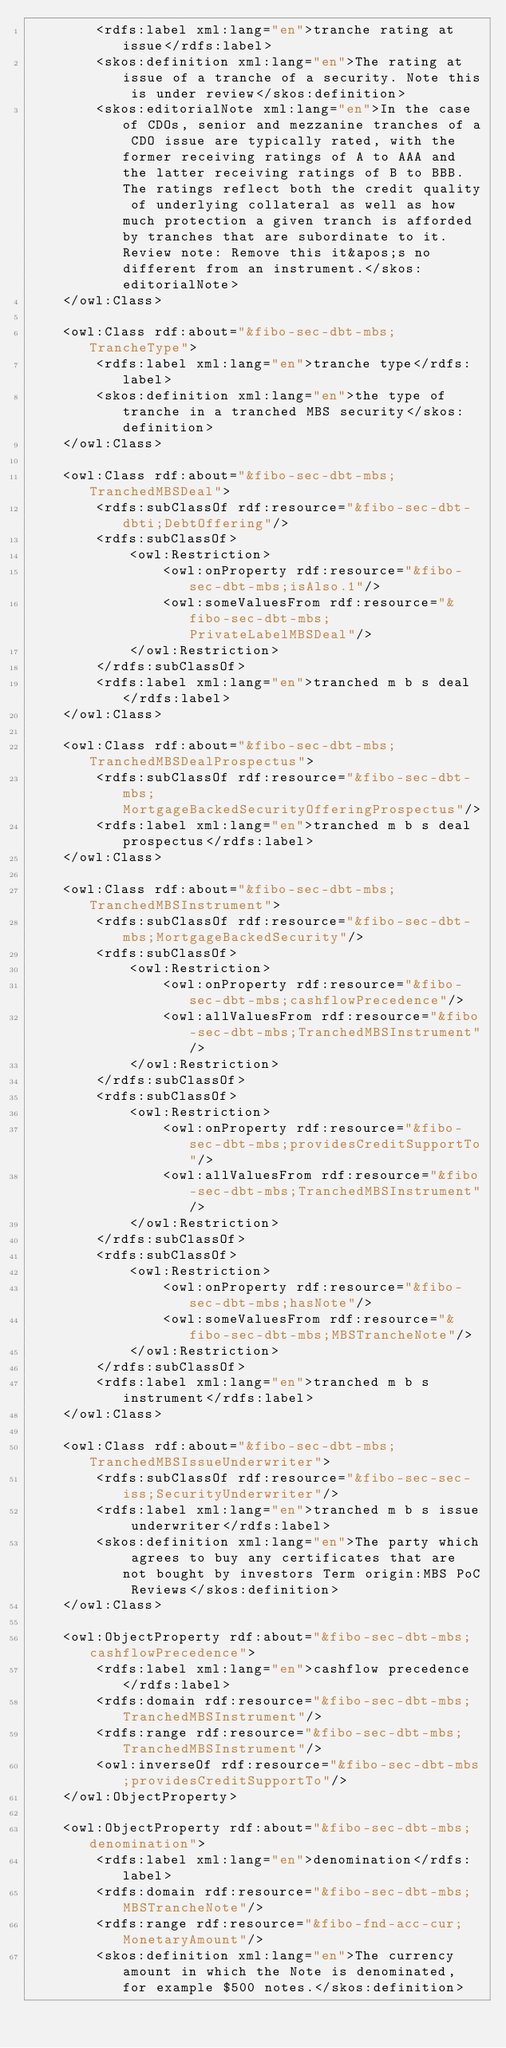Convert code to text. <code><loc_0><loc_0><loc_500><loc_500><_XML_>		<rdfs:label xml:lang="en">tranche rating at issue</rdfs:label>
		<skos:definition xml:lang="en">The rating at issue of a tranche of a security. Note this is under review</skos:definition>
		<skos:editorialNote xml:lang="en">In the case of CDOs, senior and mezzanine tranches of a CDO issue are typically rated, with the former receiving ratings of A to AAA and the latter receiving ratings of B to BBB. The ratings reflect both the credit quality of underlying collateral as well as how much protection a given tranch is afforded by tranches that are subordinate to it. Review note: Remove this it&apos;s no different from an instrument.</skos:editorialNote>
	</owl:Class>
	
	<owl:Class rdf:about="&fibo-sec-dbt-mbs;TrancheType">
		<rdfs:label xml:lang="en">tranche type</rdfs:label>
		<skos:definition xml:lang="en">the type of tranche in a tranched MBS security</skos:definition>
	</owl:Class>
	
	<owl:Class rdf:about="&fibo-sec-dbt-mbs;TranchedMBSDeal">
		<rdfs:subClassOf rdf:resource="&fibo-sec-dbt-dbti;DebtOffering"/>
		<rdfs:subClassOf>
			<owl:Restriction>
				<owl:onProperty rdf:resource="&fibo-sec-dbt-mbs;isAlso.1"/>
				<owl:someValuesFrom rdf:resource="&fibo-sec-dbt-mbs;PrivateLabelMBSDeal"/>
			</owl:Restriction>
		</rdfs:subClassOf>
		<rdfs:label xml:lang="en">tranched m b s deal</rdfs:label>
	</owl:Class>
	
	<owl:Class rdf:about="&fibo-sec-dbt-mbs;TranchedMBSDealProspectus">
		<rdfs:subClassOf rdf:resource="&fibo-sec-dbt-mbs;MortgageBackedSecurityOfferingProspectus"/>
		<rdfs:label xml:lang="en">tranched m b s deal prospectus</rdfs:label>
	</owl:Class>
	
	<owl:Class rdf:about="&fibo-sec-dbt-mbs;TranchedMBSInstrument">
		<rdfs:subClassOf rdf:resource="&fibo-sec-dbt-mbs;MortgageBackedSecurity"/>
		<rdfs:subClassOf>
			<owl:Restriction>
				<owl:onProperty rdf:resource="&fibo-sec-dbt-mbs;cashflowPrecedence"/>
				<owl:allValuesFrom rdf:resource="&fibo-sec-dbt-mbs;TranchedMBSInstrument"/>
			</owl:Restriction>
		</rdfs:subClassOf>
		<rdfs:subClassOf>
			<owl:Restriction>
				<owl:onProperty rdf:resource="&fibo-sec-dbt-mbs;providesCreditSupportTo"/>
				<owl:allValuesFrom rdf:resource="&fibo-sec-dbt-mbs;TranchedMBSInstrument"/>
			</owl:Restriction>
		</rdfs:subClassOf>
		<rdfs:subClassOf>
			<owl:Restriction>
				<owl:onProperty rdf:resource="&fibo-sec-dbt-mbs;hasNote"/>
				<owl:someValuesFrom rdf:resource="&fibo-sec-dbt-mbs;MBSTrancheNote"/>
			</owl:Restriction>
		</rdfs:subClassOf>
		<rdfs:label xml:lang="en">tranched m b s instrument</rdfs:label>
	</owl:Class>
	
	<owl:Class rdf:about="&fibo-sec-dbt-mbs;TranchedMBSIssueUnderwriter">
		<rdfs:subClassOf rdf:resource="&fibo-sec-sec-iss;SecurityUnderwriter"/>
		<rdfs:label xml:lang="en">tranched m b s issue underwriter</rdfs:label>
		<skos:definition xml:lang="en">The party which agrees to buy any certificates that are not bought by investors Term origin:MBS PoC Reviews</skos:definition>
	</owl:Class>
	
	<owl:ObjectProperty rdf:about="&fibo-sec-dbt-mbs;cashflowPrecedence">
		<rdfs:label xml:lang="en">cashflow precedence</rdfs:label>
		<rdfs:domain rdf:resource="&fibo-sec-dbt-mbs;TranchedMBSInstrument"/>
		<rdfs:range rdf:resource="&fibo-sec-dbt-mbs;TranchedMBSInstrument"/>
		<owl:inverseOf rdf:resource="&fibo-sec-dbt-mbs;providesCreditSupportTo"/>
	</owl:ObjectProperty>
	
	<owl:ObjectProperty rdf:about="&fibo-sec-dbt-mbs;denomination">
		<rdfs:label xml:lang="en">denomination</rdfs:label>
		<rdfs:domain rdf:resource="&fibo-sec-dbt-mbs;MBSTrancheNote"/>
		<rdfs:range rdf:resource="&fibo-fnd-acc-cur;MonetaryAmount"/>
		<skos:definition xml:lang="en">The currency amount in which the Note is denominated, for example $500 notes.</skos:definition></code> 